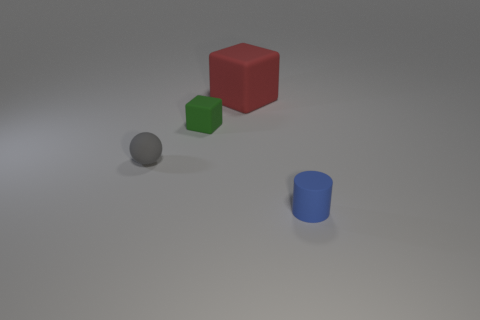Is there any other thing that is the same size as the red rubber thing?
Ensure brevity in your answer.  No. What material is the tiny object that is both on the left side of the large block and in front of the small green cube?
Offer a terse response. Rubber. There is a small rubber object to the left of the small matte block; does it have the same shape as the matte thing behind the tiny green thing?
Keep it short and to the point. No. There is a object that is on the left side of the block left of the cube that is behind the tiny cube; what is its shape?
Your answer should be compact. Sphere. How many other objects are the same shape as the red thing?
Provide a short and direct response. 1. There is a matte sphere that is the same size as the green block; what color is it?
Provide a succinct answer. Gray. What number of cubes are either tiny cyan things or big rubber objects?
Give a very brief answer. 1. How many big red rubber cubes are there?
Ensure brevity in your answer.  1. There is a red object; is its shape the same as the small rubber thing behind the gray rubber ball?
Offer a terse response. Yes. How many objects are balls or small cylinders?
Give a very brief answer. 2. 